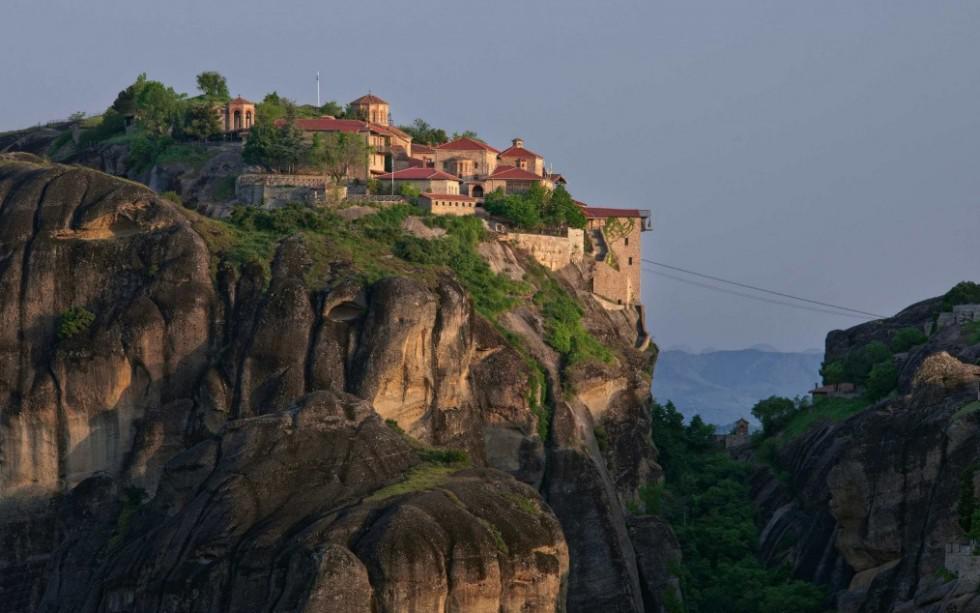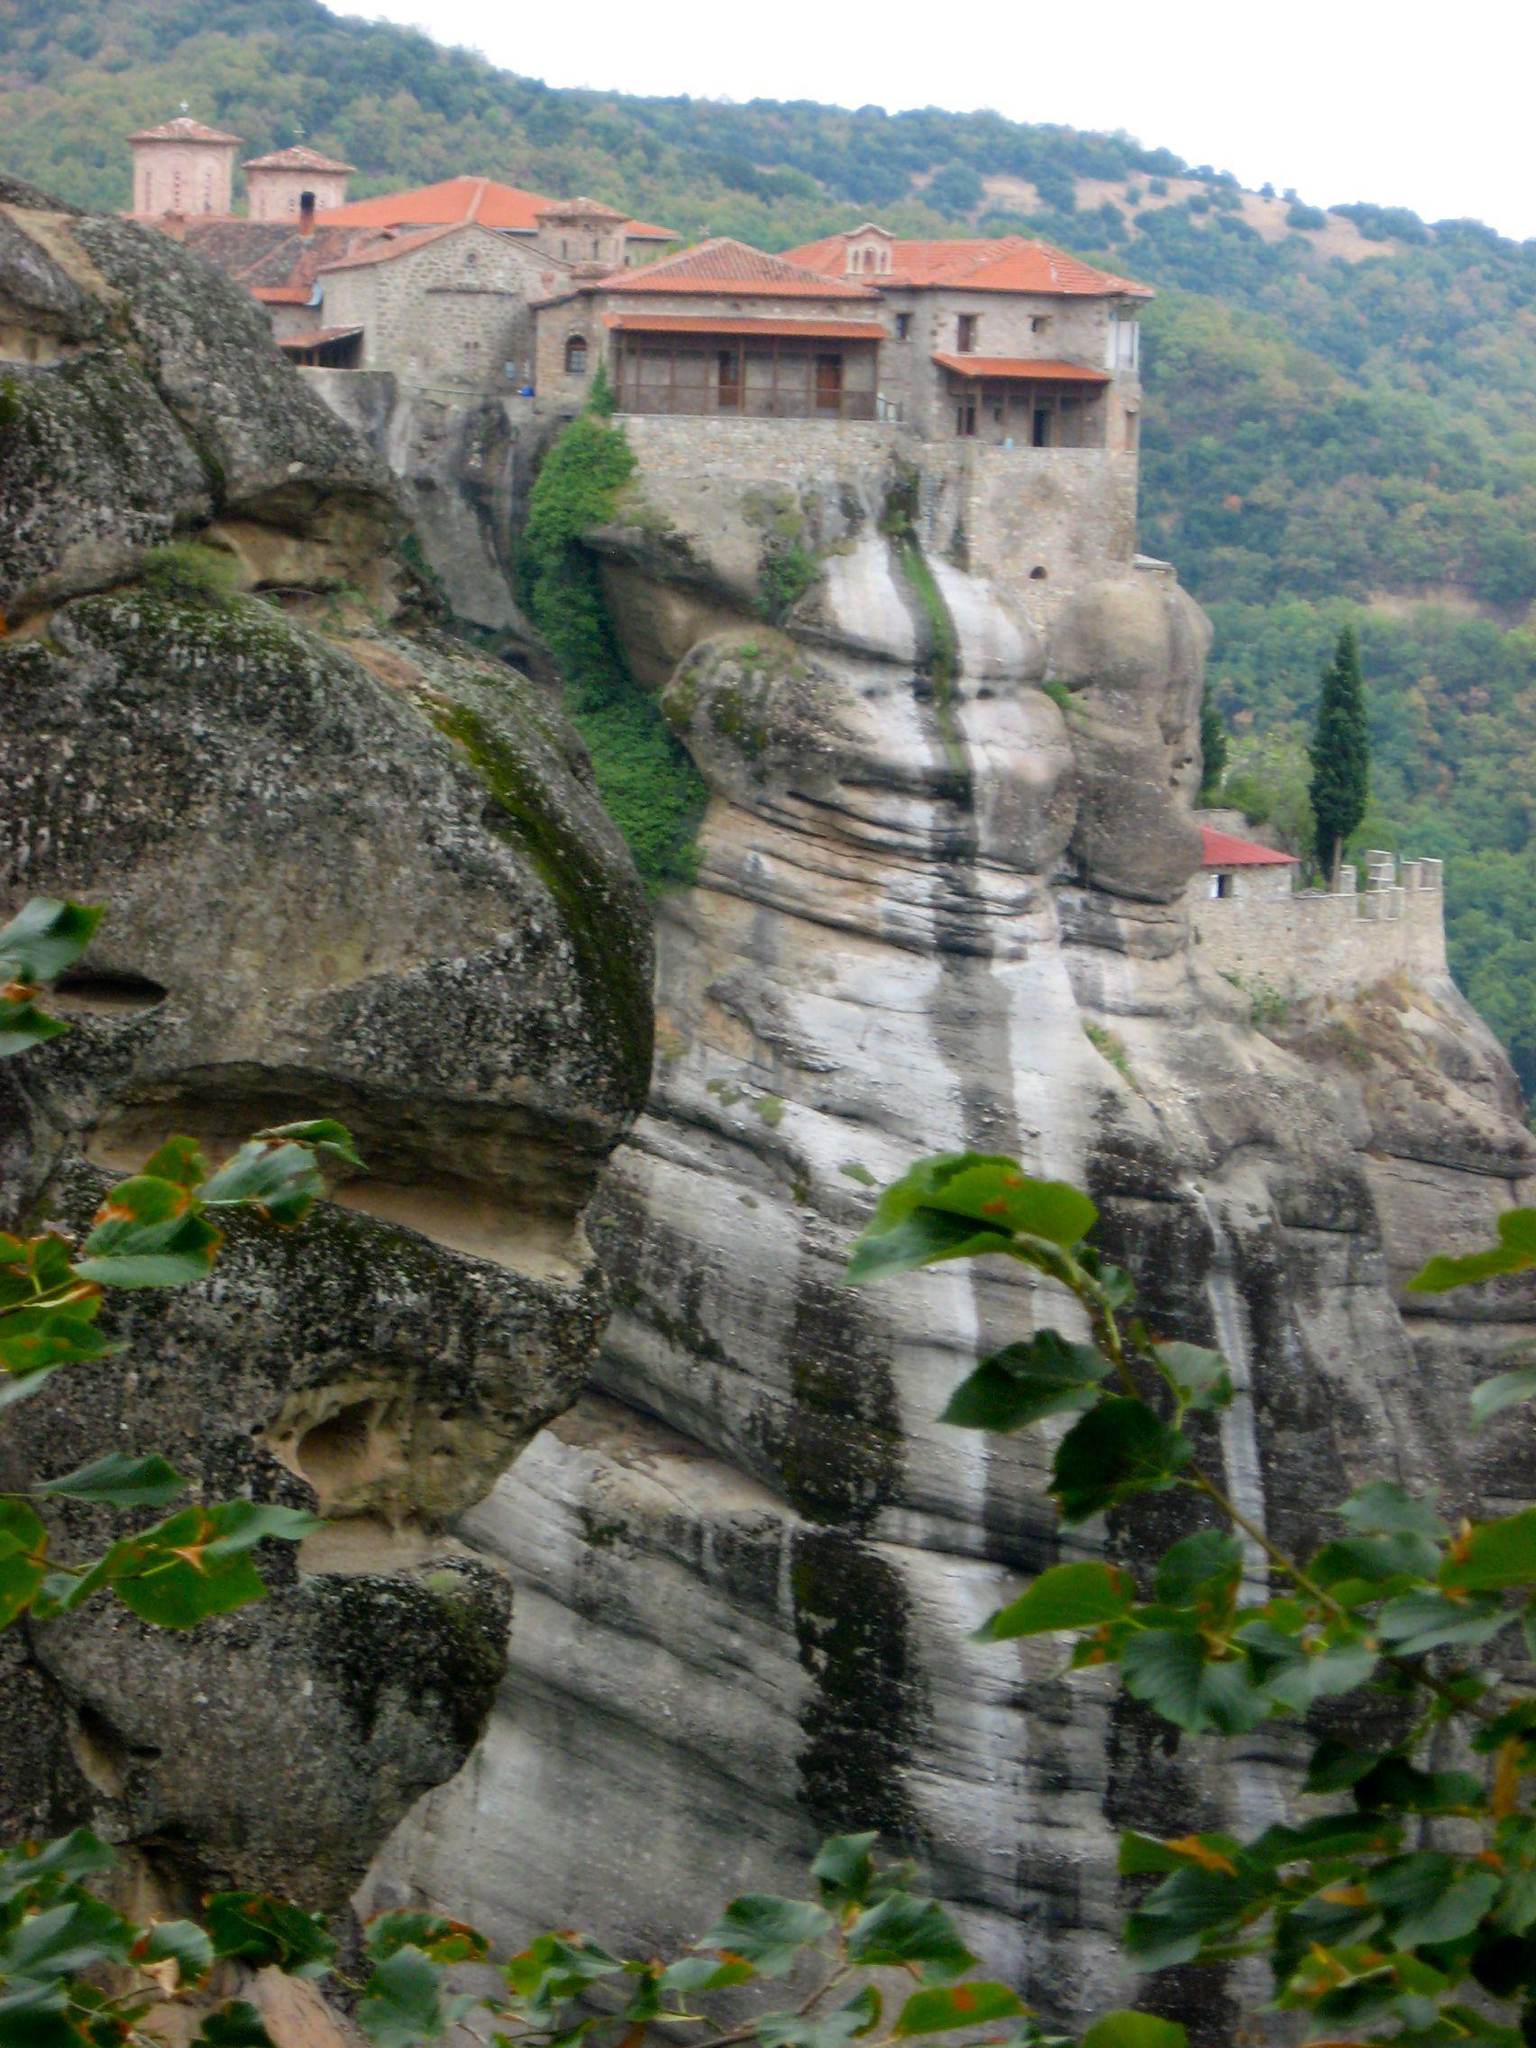The first image is the image on the left, the second image is the image on the right. Given the left and right images, does the statement "Both images show a sky above the buildings on the cliffs." hold true? Answer yes or no. Yes. The first image is the image on the left, the second image is the image on the right. For the images displayed, is the sentence "These images feature a home on a cliff side from the same angle, and from a similar distance." factually correct? Answer yes or no. No. 